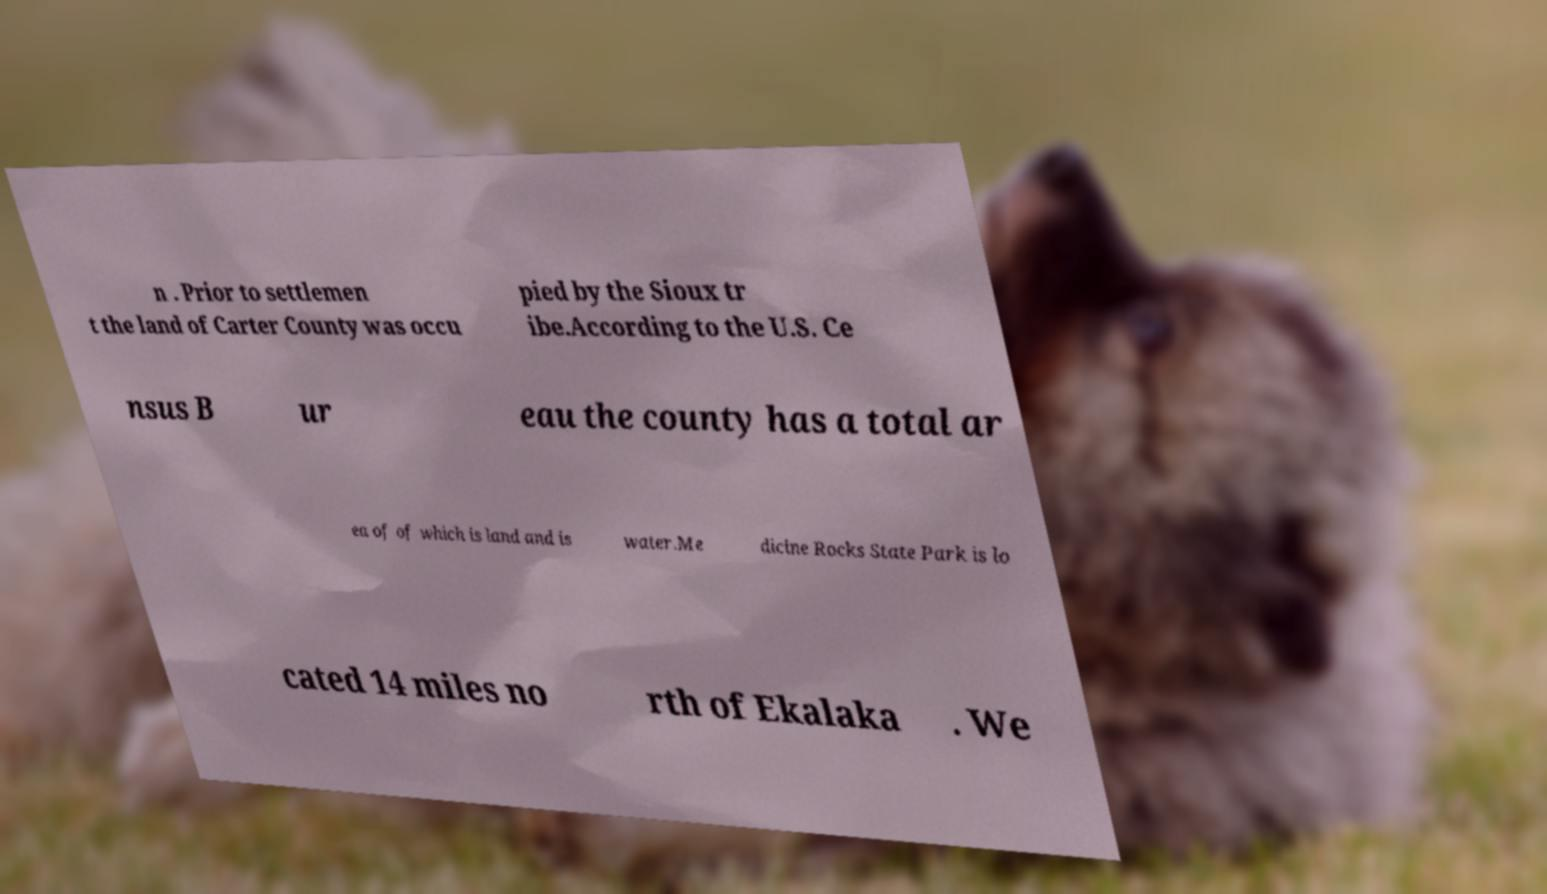What messages or text are displayed in this image? I need them in a readable, typed format. n . Prior to settlemen t the land of Carter County was occu pied by the Sioux tr ibe.According to the U.S. Ce nsus B ur eau the county has a total ar ea of of which is land and is water.Me dicine Rocks State Park is lo cated 14 miles no rth of Ekalaka . We 